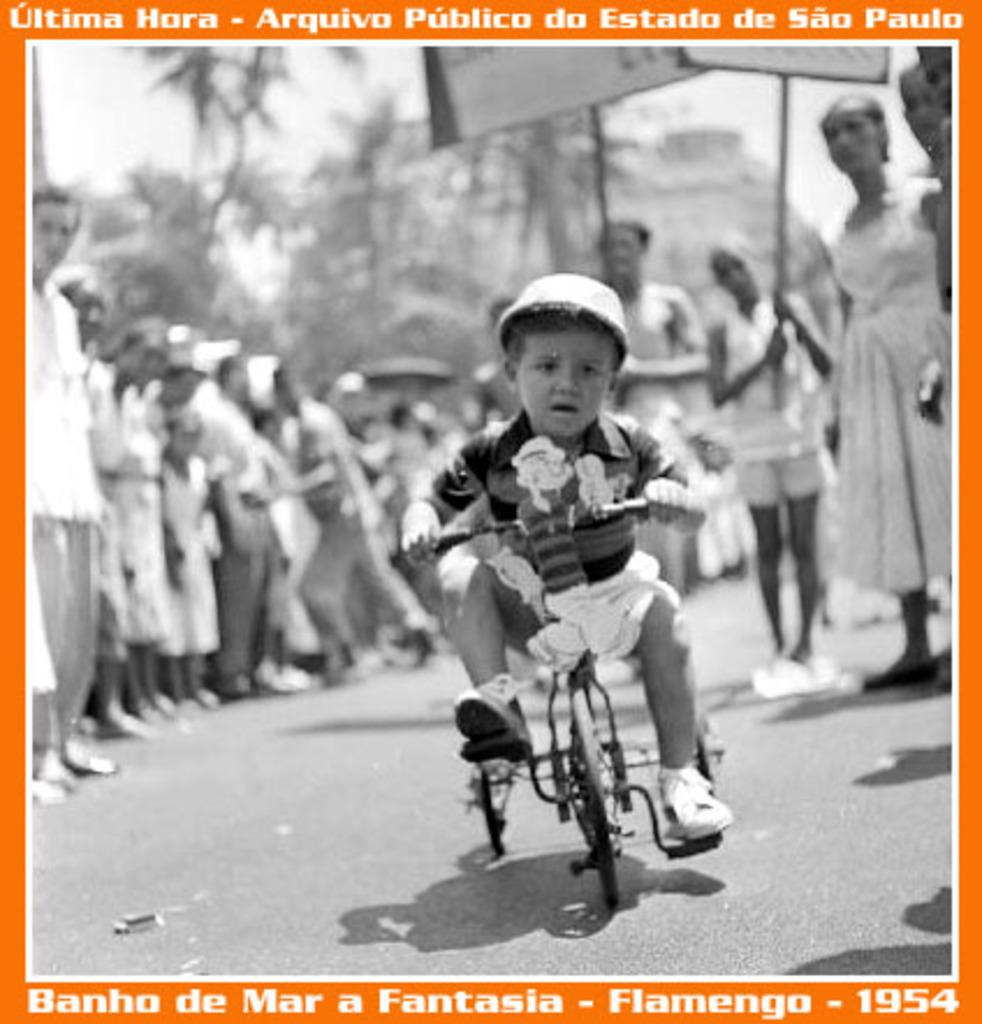What is the child in the image doing? The child is cycling a tricycle in the image. What safety precaution is the child taking while cycling? The child is wearing a helmet while cycling. Can you describe the people in the background of the image? There are people standing in the background of the image. What type of quilt is being used to cover the selection of glassware in the image? There is no quilt or glassware present in the image; it features a child cycling a tricycle and people standing in the background. 